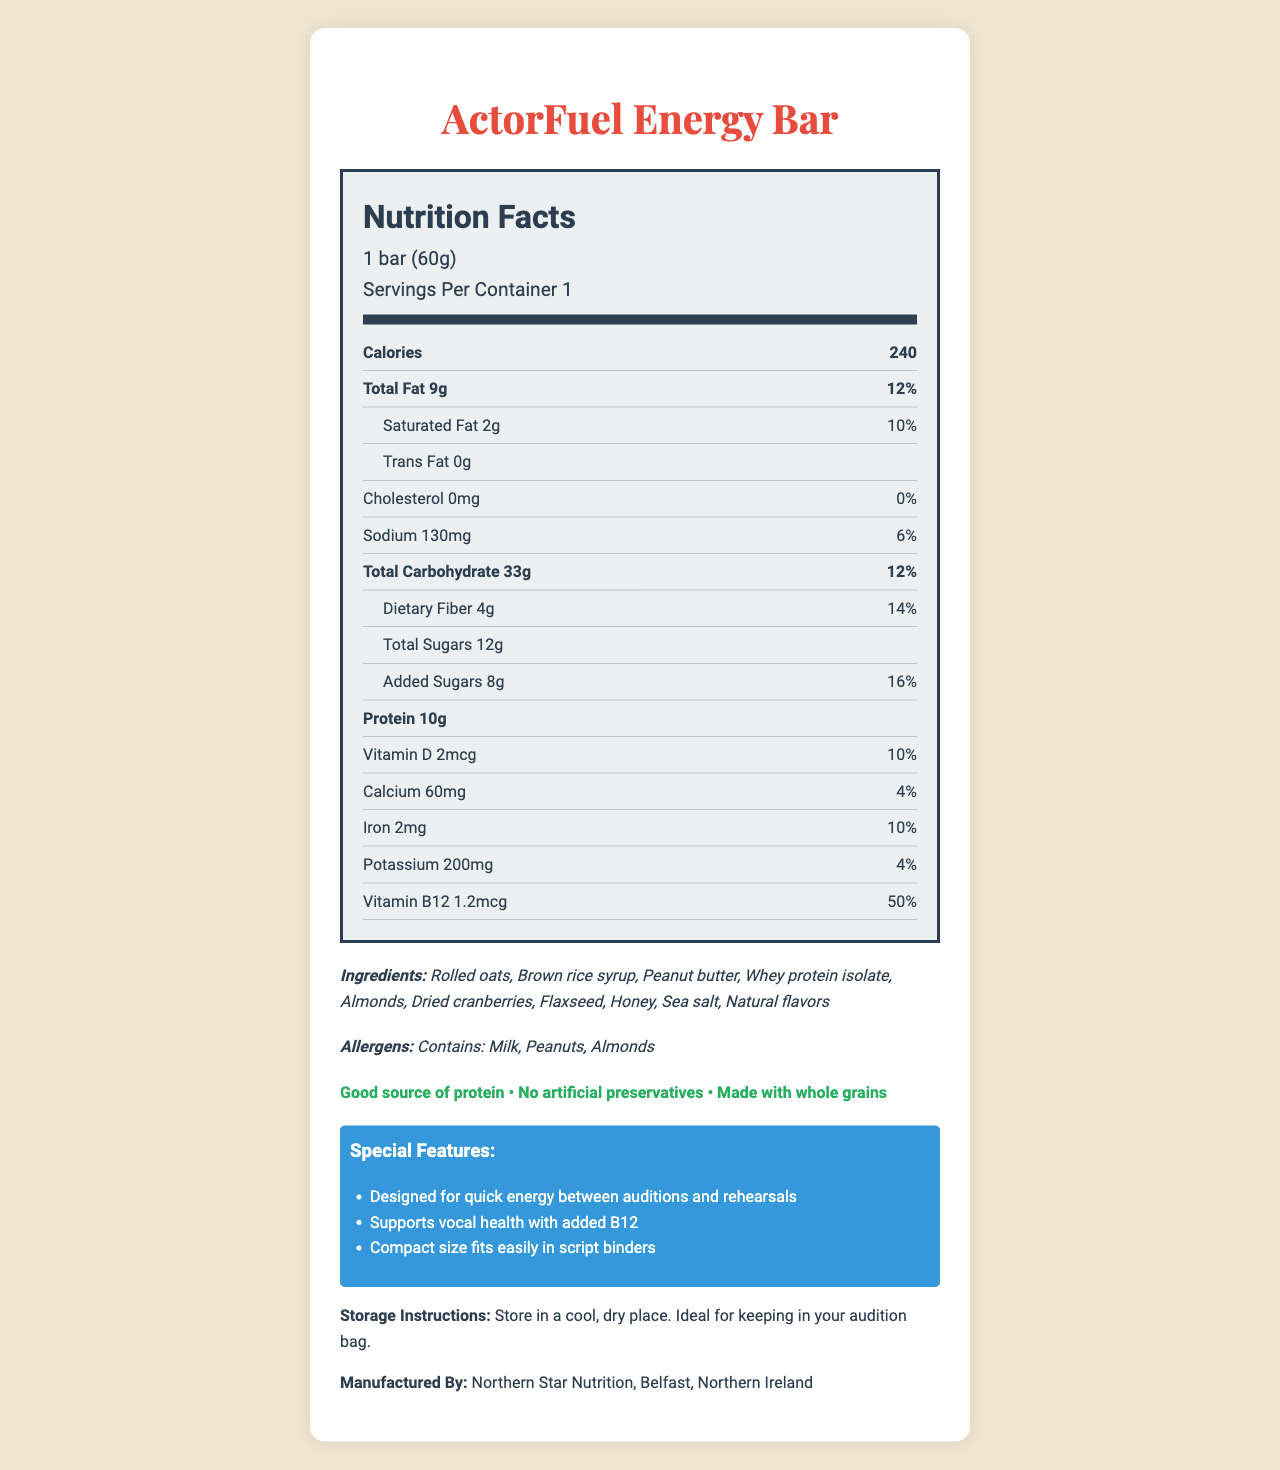how much protein does one bar contain? The nutrition label lists the protein content directly as 10g per serving.
Answer: 10g what is the serving size of the ActorFuel Energy Bar? The serving size is mentioned at the top of the nutrition label.
Answer: 1 bar (60g) what is the percentage of daily value for Vitamin B12 in this bar? The nutrition label lists the daily value of Vitamin B12 as 50%.
Answer: 50% which allergens are present in the ActorFuel Energy Bar? The allergens section of the document explicitly lists Milk, Peanuts, and Almonds.
Answer: Milk, Peanuts, Almonds how many calories are in one serving of the ActorFuel Energy Bar? The calories per serving are stated directly on the nutrition label.
Answer: 240 what is the total carbohydrate content of the energy bar? A. 25g B. 29g C. 33g D. 37g The nutrition label lists the total carbohydrate content as 33g.
Answer: C. 33g how much iron is in the ActorFuel Energy Bar? A. 1mg B. 2mg C. 3mg D. 4mg The amount of iron is listed as 2mg on the nutrition label.
Answer: B. 2mg is the energy bar designed to support vocal health? One of the special features mentioned is that it supports vocal health with added B12.
Answer: Yes does the energy bar contain any trans fat? The nutrition label shows 0g of trans fat.
Answer: No summarize the key features and nutritional elements of the ActorFuel Energy Bar. The document describes the nutritional content, special features, intended use, ingredients, and allergens of the ActorFuel Energy Bar, emphasizing its suitability for actors needing quick nutrition.
Answer: The ActorFuel Energy Bar is a 60g energy bar providing 240 calories per serving, designed for quick energy between auditions and rehearsals. It's a good source of protein (10g), contains key vitamins like B12 (50% DV), and is made with whole grains without artificial preservatives. Ingredients include rolled oats, peanut butter, and dried cranberries. It contains milk, peanuts, and almonds as allergens. do the storage instructions suggest keeping the bar in a warm place? The storage instructions recommend storing the bar in a cool, dry place.
Answer: No what is the amount of added sugars in the ActorFuel Energy Bar? The nutrition label shows the added sugars content as 8g.
Answer: 8g what is the company's name that manufactures the ActorFuel Energy Bar? The document states that the energy bar is manufactured by Northern Star Nutrition in Belfast, Northern Ireland.
Answer: Northern Star Nutrition can you use this document to determine the cost of the ActorFuel Energy Bar? The document does not contain any information regarding the price of the energy bar.
Answer: Not enough information how many grams of dietary fiber are in the energy bar? The nutrition label indicates that there are 4g of dietary fiber in one serving.
Answer: 4g what is the sodium content in the energy bar? The nutrition label lists the sodium content as 130mg.
Answer: 130mg which item is not explicitly mentioned in the ingredient list? A. Rolled oats B. Brown rice syrup C. Chocolate chips D. Peanut butter The ingredient list includes rolled oats, brown rice syrup, and peanut butter, but not chocolate chips.
Answer: C. Chocolate chips 